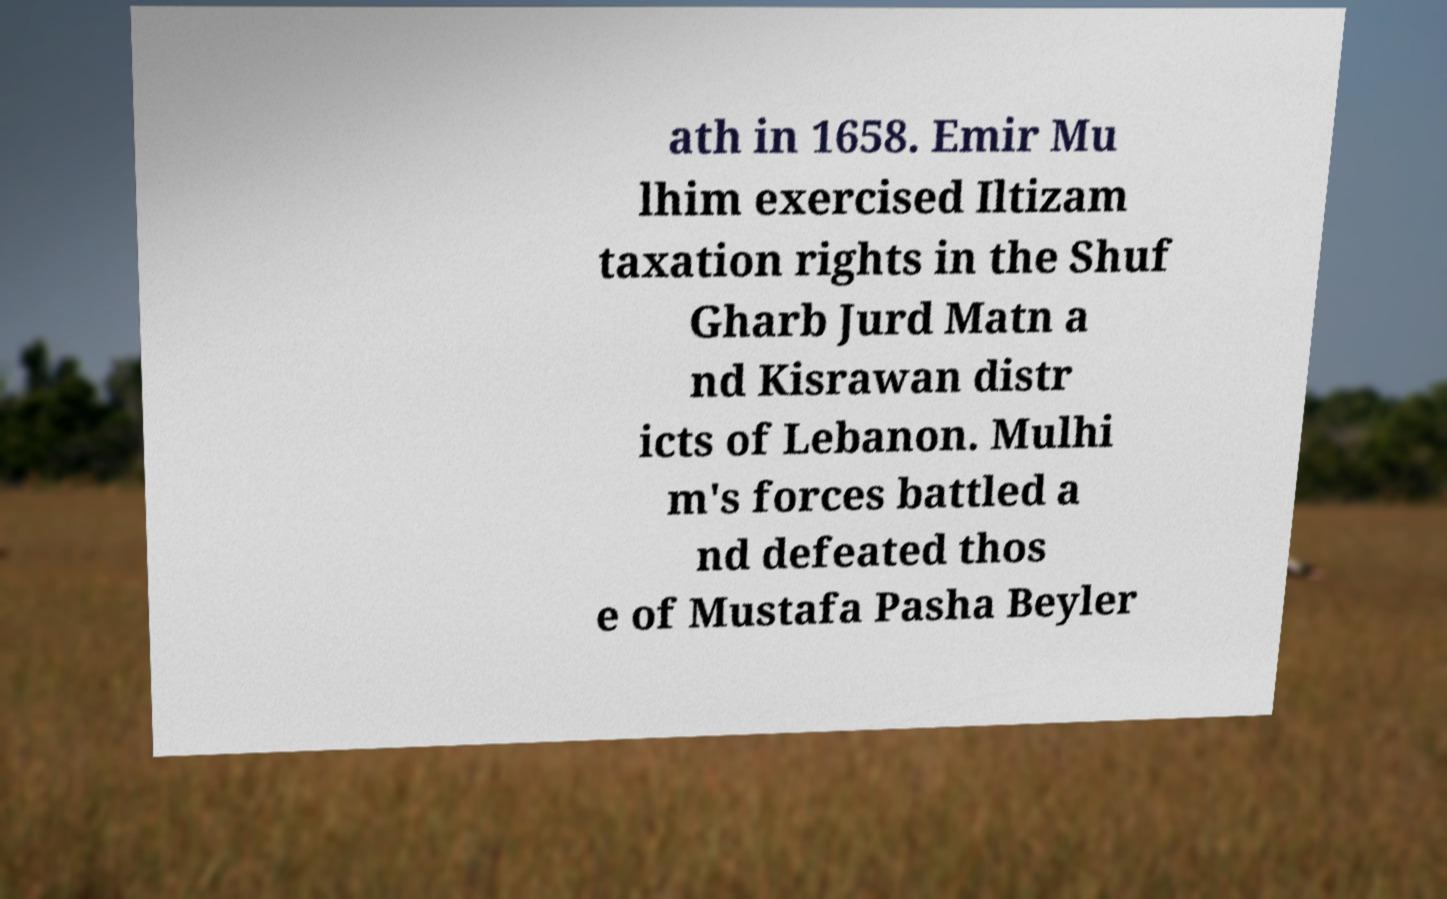Could you assist in decoding the text presented in this image and type it out clearly? ath in 1658. Emir Mu lhim exercised Iltizam taxation rights in the Shuf Gharb Jurd Matn a nd Kisrawan distr icts of Lebanon. Mulhi m's forces battled a nd defeated thos e of Mustafa Pasha Beyler 